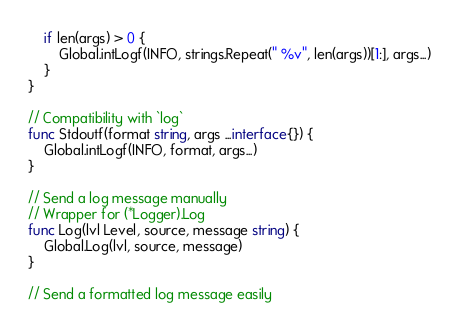<code> <loc_0><loc_0><loc_500><loc_500><_Go_>	if len(args) > 0 {
		Global.intLogf(INFO, strings.Repeat(" %v", len(args))[1:], args...)
	}
}

// Compatibility with `log`
func Stdoutf(format string, args ...interface{}) {
	Global.intLogf(INFO, format, args...)
}

// Send a log message manually
// Wrapper for (*Logger).Log
func Log(lvl Level, source, message string) {
	Global.Log(lvl, source, message)
}

// Send a formatted log message easily</code> 